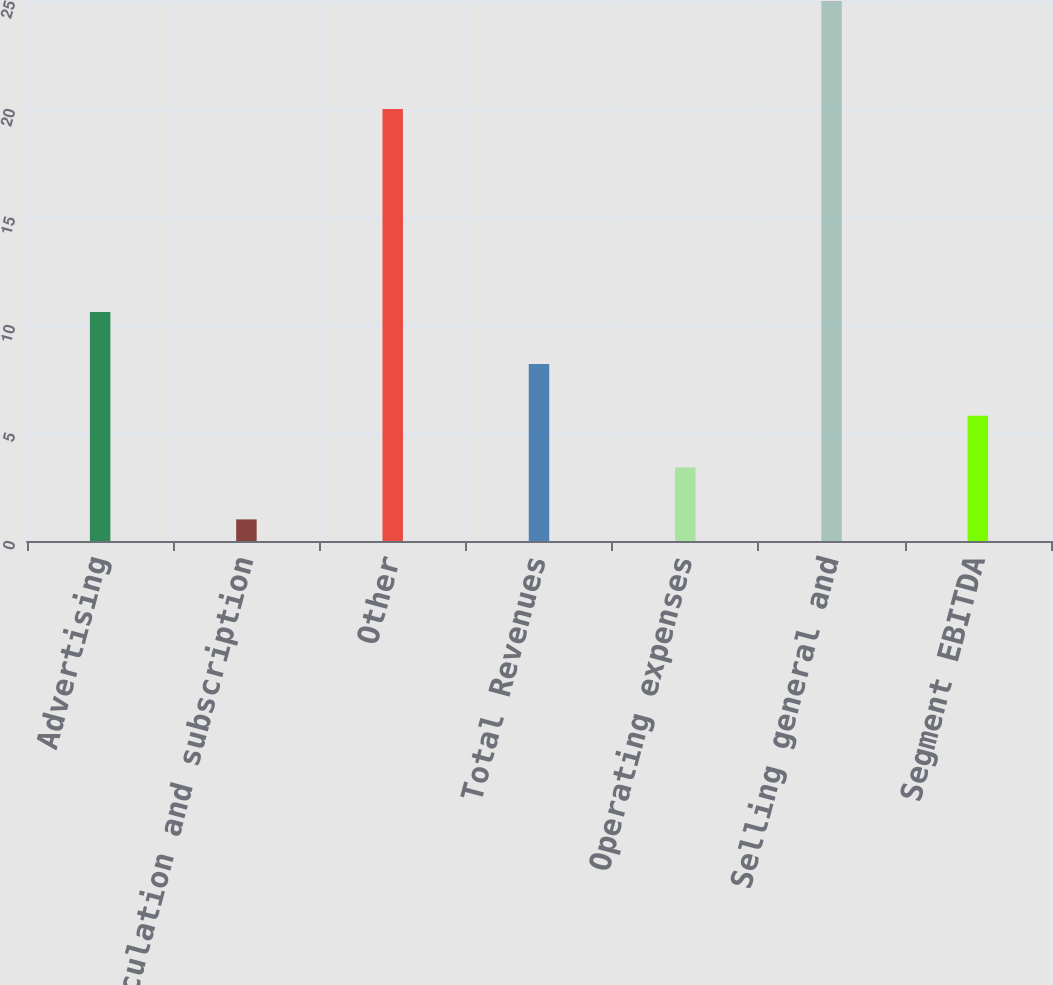<chart> <loc_0><loc_0><loc_500><loc_500><bar_chart><fcel>Advertising<fcel>Circulation and subscription<fcel>Other<fcel>Total Revenues<fcel>Operating expenses<fcel>Selling general and<fcel>Segment EBITDA<nl><fcel>10.6<fcel>1<fcel>20<fcel>8.2<fcel>3.4<fcel>25<fcel>5.8<nl></chart> 